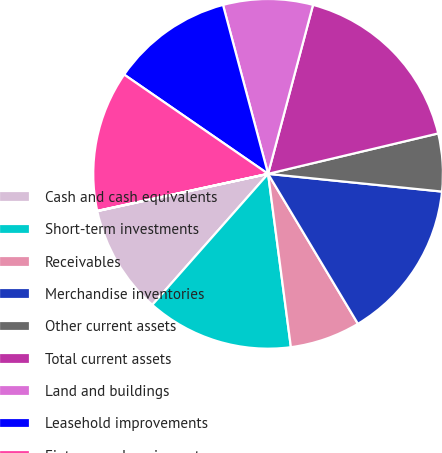<chart> <loc_0><loc_0><loc_500><loc_500><pie_chart><fcel>Cash and cash equivalents<fcel>Short-term investments<fcel>Receivables<fcel>Merchandise inventories<fcel>Other current assets<fcel>Total current assets<fcel>Land and buildings<fcel>Leasehold improvements<fcel>Fixtures and equipment<fcel>Property under capital lease<nl><fcel>10.06%<fcel>13.6%<fcel>6.51%<fcel>14.79%<fcel>5.33%<fcel>17.15%<fcel>8.29%<fcel>11.24%<fcel>13.01%<fcel>0.02%<nl></chart> 